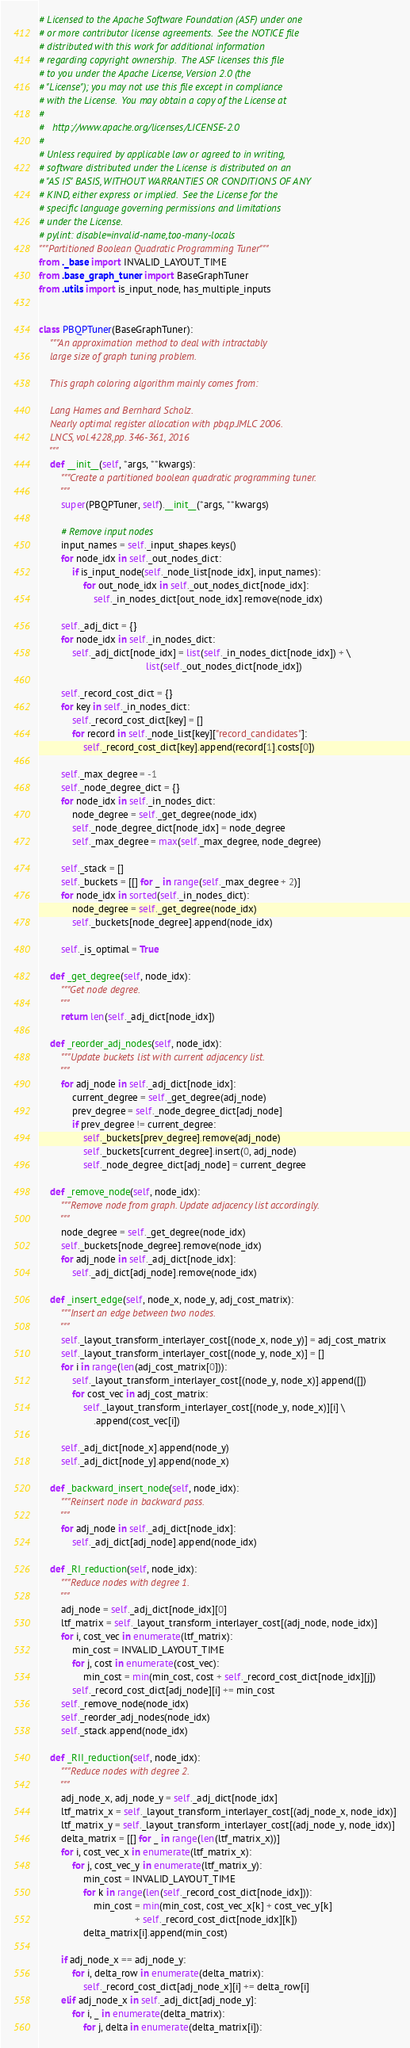<code> <loc_0><loc_0><loc_500><loc_500><_Python_># Licensed to the Apache Software Foundation (ASF) under one
# or more contributor license agreements.  See the NOTICE file
# distributed with this work for additional information
# regarding copyright ownership.  The ASF licenses this file
# to you under the Apache License, Version 2.0 (the
# "License"); you may not use this file except in compliance
# with the License.  You may obtain a copy of the License at
#
#   http://www.apache.org/licenses/LICENSE-2.0
#
# Unless required by applicable law or agreed to in writing,
# software distributed under the License is distributed on an
# "AS IS" BASIS, WITHOUT WARRANTIES OR CONDITIONS OF ANY
# KIND, either express or implied.  See the License for the
# specific language governing permissions and limitations
# under the License.
# pylint: disable=invalid-name,too-many-locals
"""Partitioned Boolean Quadratic Programming Tuner"""
from ._base import INVALID_LAYOUT_TIME
from .base_graph_tuner import BaseGraphTuner
from .utils import is_input_node, has_multiple_inputs


class PBQPTuner(BaseGraphTuner):
    """An approximation method to deal with intractably
    large size of graph tuning problem.

    This graph coloring algorithm mainly comes from:

    Lang Hames and Bernhard Scholz.
    Nearly optimal register allocation with pbqp.JMLC 2006.
    LNCS, vol.4228,pp. 346-361, 2016
    """
    def __init__(self, *args, **kwargs):
        """Create a partitioned boolean quadratic programming tuner.
        """
        super(PBQPTuner, self).__init__(*args, **kwargs)

        # Remove input nodes
        input_names = self._input_shapes.keys()
        for node_idx in self._out_nodes_dict:
            if is_input_node(self._node_list[node_idx], input_names):
                for out_node_idx in self._out_nodes_dict[node_idx]:
                    self._in_nodes_dict[out_node_idx].remove(node_idx)

        self._adj_dict = {}
        for node_idx in self._in_nodes_dict:
            self._adj_dict[node_idx] = list(self._in_nodes_dict[node_idx]) + \
                                       list(self._out_nodes_dict[node_idx])

        self._record_cost_dict = {}
        for key in self._in_nodes_dict:
            self._record_cost_dict[key] = []
            for record in self._node_list[key]["record_candidates"]:
                self._record_cost_dict[key].append(record[1].costs[0])

        self._max_degree = -1
        self._node_degree_dict = {}
        for node_idx in self._in_nodes_dict:
            node_degree = self._get_degree(node_idx)
            self._node_degree_dict[node_idx] = node_degree
            self._max_degree = max(self._max_degree, node_degree)

        self._stack = []
        self._buckets = [[] for _ in range(self._max_degree + 2)]
        for node_idx in sorted(self._in_nodes_dict):
            node_degree = self._get_degree(node_idx)
            self._buckets[node_degree].append(node_idx)

        self._is_optimal = True

    def _get_degree(self, node_idx):
        """Get node degree.
        """
        return len(self._adj_dict[node_idx])

    def _reorder_adj_nodes(self, node_idx):
        """Update buckets list with current adjacency list.
        """
        for adj_node in self._adj_dict[node_idx]:
            current_degree = self._get_degree(adj_node)
            prev_degree = self._node_degree_dict[adj_node]
            if prev_degree != current_degree:
                self._buckets[prev_degree].remove(adj_node)
                self._buckets[current_degree].insert(0, adj_node)
                self._node_degree_dict[adj_node] = current_degree

    def _remove_node(self, node_idx):
        """Remove node from graph. Update adjacency list accordingly.
        """
        node_degree = self._get_degree(node_idx)
        self._buckets[node_degree].remove(node_idx)
        for adj_node in self._adj_dict[node_idx]:
            self._adj_dict[adj_node].remove(node_idx)

    def _insert_edge(self, node_x, node_y, adj_cost_matrix):
        """Insert an edge between two nodes.
        """
        self._layout_transform_interlayer_cost[(node_x, node_y)] = adj_cost_matrix
        self._layout_transform_interlayer_cost[(node_y, node_x)] = []
        for i in range(len(adj_cost_matrix[0])):
            self._layout_transform_interlayer_cost[(node_y, node_x)].append([])
            for cost_vec in adj_cost_matrix:
                self._layout_transform_interlayer_cost[(node_y, node_x)][i] \
                    .append(cost_vec[i])

        self._adj_dict[node_x].append(node_y)
        self._adj_dict[node_y].append(node_x)

    def _backward_insert_node(self, node_idx):
        """Reinsert node in backward pass.
        """
        for adj_node in self._adj_dict[node_idx]:
            self._adj_dict[adj_node].append(node_idx)

    def _RI_reduction(self, node_idx):
        """Reduce nodes with degree 1.
        """
        adj_node = self._adj_dict[node_idx][0]
        ltf_matrix = self._layout_transform_interlayer_cost[(adj_node, node_idx)]
        for i, cost_vec in enumerate(ltf_matrix):
            min_cost = INVALID_LAYOUT_TIME
            for j, cost in enumerate(cost_vec):
                min_cost = min(min_cost, cost + self._record_cost_dict[node_idx][j])
            self._record_cost_dict[adj_node][i] += min_cost
        self._remove_node(node_idx)
        self._reorder_adj_nodes(node_idx)
        self._stack.append(node_idx)

    def _RII_reduction(self, node_idx):
        """Reduce nodes with degree 2.
        """
        adj_node_x, adj_node_y = self._adj_dict[node_idx]
        ltf_matrix_x = self._layout_transform_interlayer_cost[(adj_node_x, node_idx)]
        ltf_matrix_y = self._layout_transform_interlayer_cost[(adj_node_y, node_idx)]
        delta_matrix = [[] for _ in range(len(ltf_matrix_x))]
        for i, cost_vec_x in enumerate(ltf_matrix_x):
            for j, cost_vec_y in enumerate(ltf_matrix_y):
                min_cost = INVALID_LAYOUT_TIME
                for k in range(len(self._record_cost_dict[node_idx])):
                    min_cost = min(min_cost, cost_vec_x[k] + cost_vec_y[k]
                                   + self._record_cost_dict[node_idx][k])
                delta_matrix[i].append(min_cost)

        if adj_node_x == adj_node_y:
            for i, delta_row in enumerate(delta_matrix):
                self._record_cost_dict[adj_node_x][i] += delta_row[i]
        elif adj_node_x in self._adj_dict[adj_node_y]:
            for i, _ in enumerate(delta_matrix):
                for j, delta in enumerate(delta_matrix[i]):</code> 